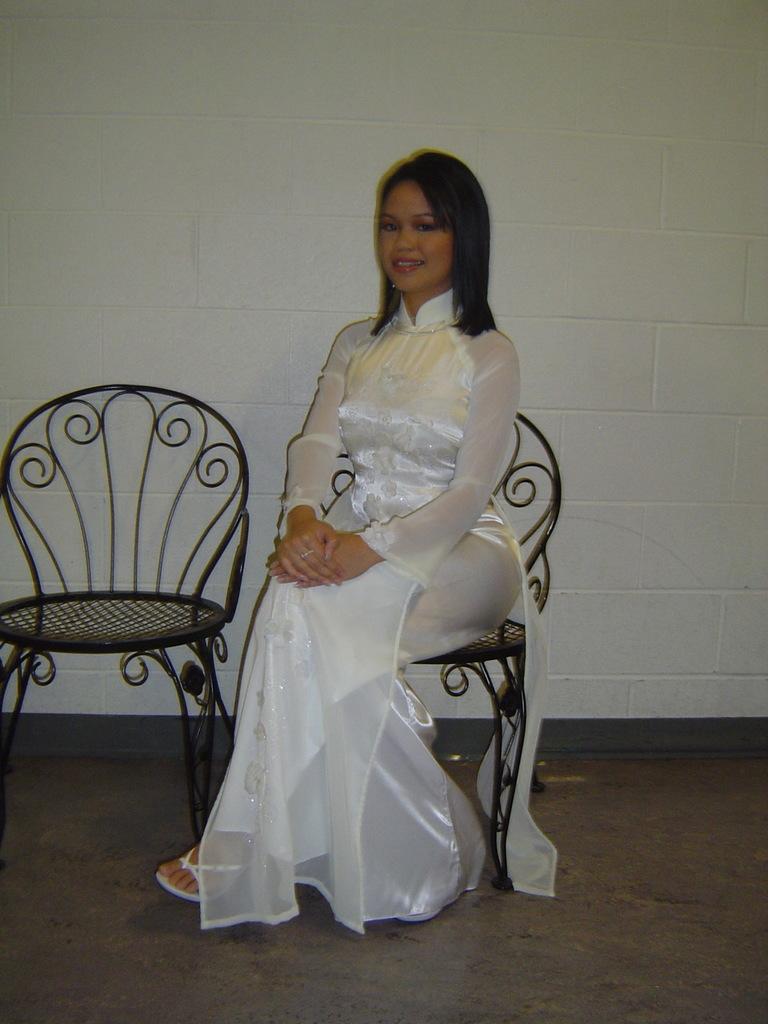Could you give a brief overview of what you see in this image? In the photograph, there is a woman wearing white color dress, she is sitting on a chair there is another empty chair beside her to the left, behind the woman there is a white color wall. 